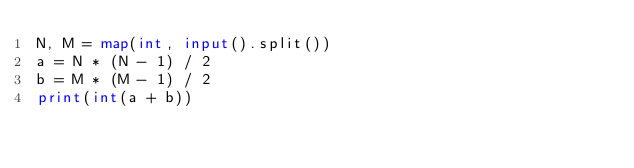Convert code to text. <code><loc_0><loc_0><loc_500><loc_500><_Python_>N, M = map(int, input().split())
a = N * (N - 1) / 2
b = M * (M - 1) / 2
print(int(a + b))</code> 